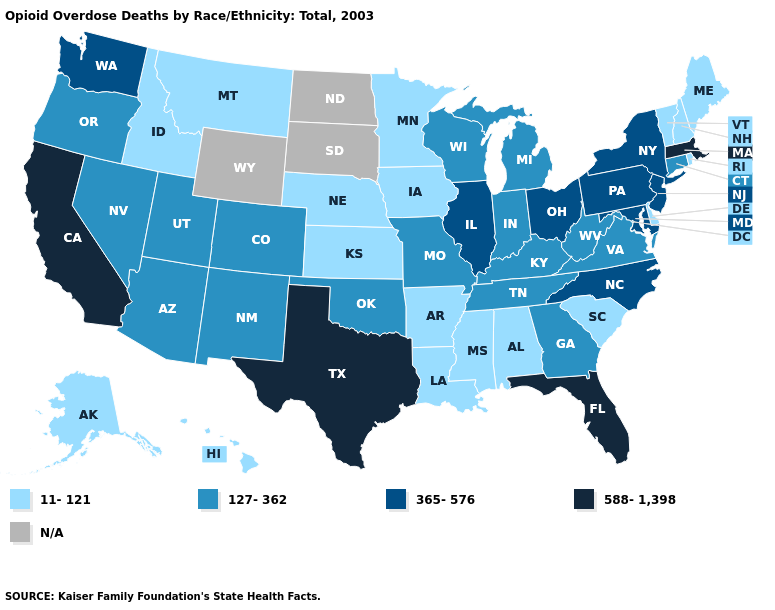Which states hav the highest value in the MidWest?
Quick response, please. Illinois, Ohio. What is the highest value in the USA?
Answer briefly. 588-1,398. What is the lowest value in the USA?
Answer briefly. 11-121. What is the highest value in states that border Oklahoma?
Be succinct. 588-1,398. Which states have the highest value in the USA?
Short answer required. California, Florida, Massachusetts, Texas. What is the value of Ohio?
Answer briefly. 365-576. Among the states that border Rhode Island , does Massachusetts have the highest value?
Answer briefly. Yes. Among the states that border Nebraska , does Colorado have the lowest value?
Short answer required. No. What is the lowest value in the West?
Concise answer only. 11-121. Does Vermont have the highest value in the Northeast?
Quick response, please. No. Does Ohio have the highest value in the MidWest?
Keep it brief. Yes. Name the states that have a value in the range 11-121?
Give a very brief answer. Alabama, Alaska, Arkansas, Delaware, Hawaii, Idaho, Iowa, Kansas, Louisiana, Maine, Minnesota, Mississippi, Montana, Nebraska, New Hampshire, Rhode Island, South Carolina, Vermont. Which states hav the highest value in the MidWest?
Write a very short answer. Illinois, Ohio. What is the lowest value in the MidWest?
Concise answer only. 11-121. 